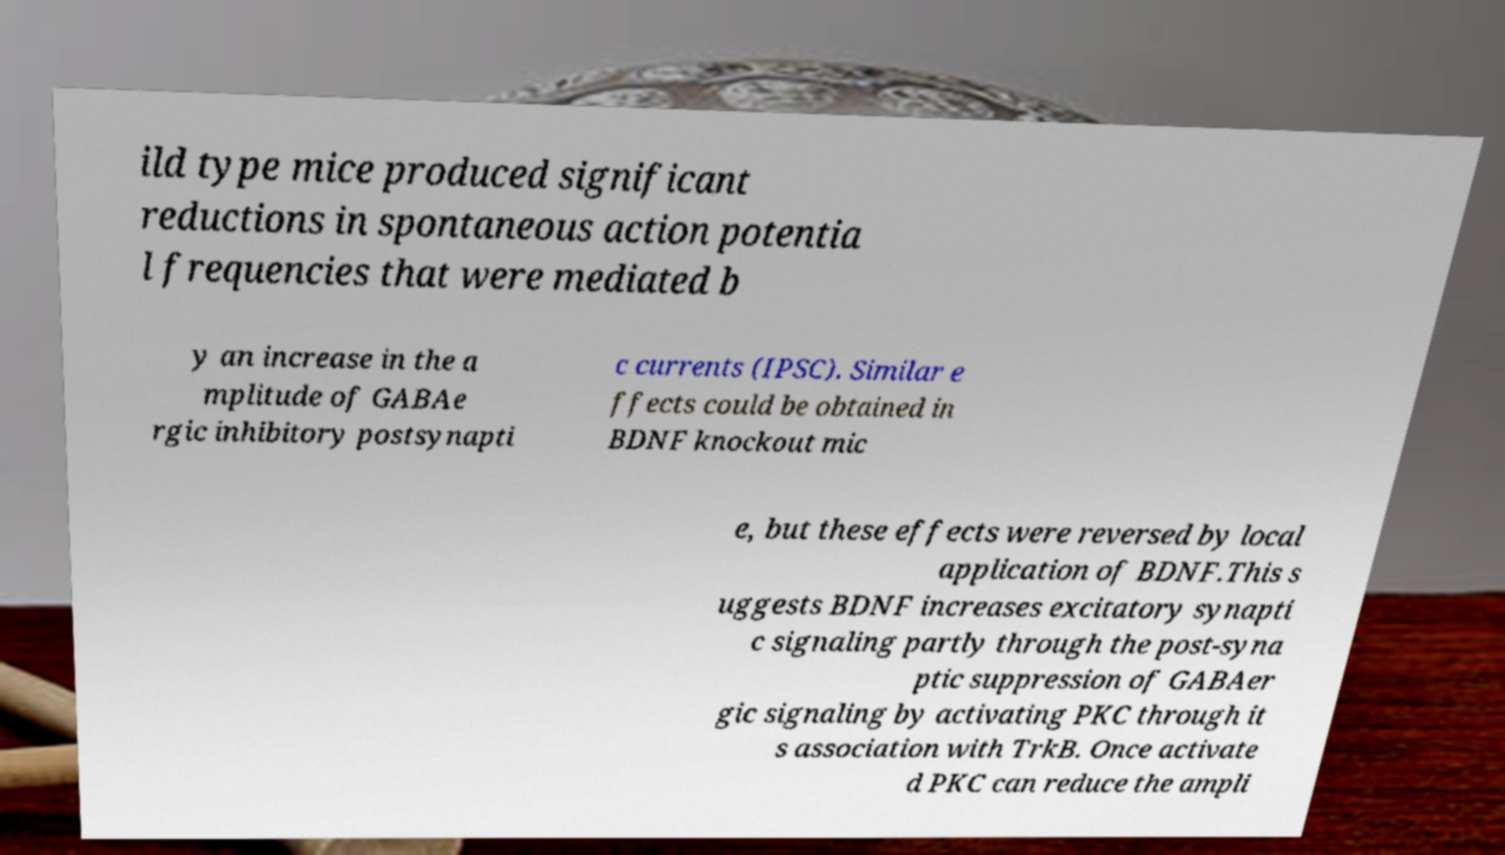Please identify and transcribe the text found in this image. ild type mice produced significant reductions in spontaneous action potentia l frequencies that were mediated b y an increase in the a mplitude of GABAe rgic inhibitory postsynapti c currents (IPSC). Similar e ffects could be obtained in BDNF knockout mic e, but these effects were reversed by local application of BDNF.This s uggests BDNF increases excitatory synapti c signaling partly through the post-syna ptic suppression of GABAer gic signaling by activating PKC through it s association with TrkB. Once activate d PKC can reduce the ampli 